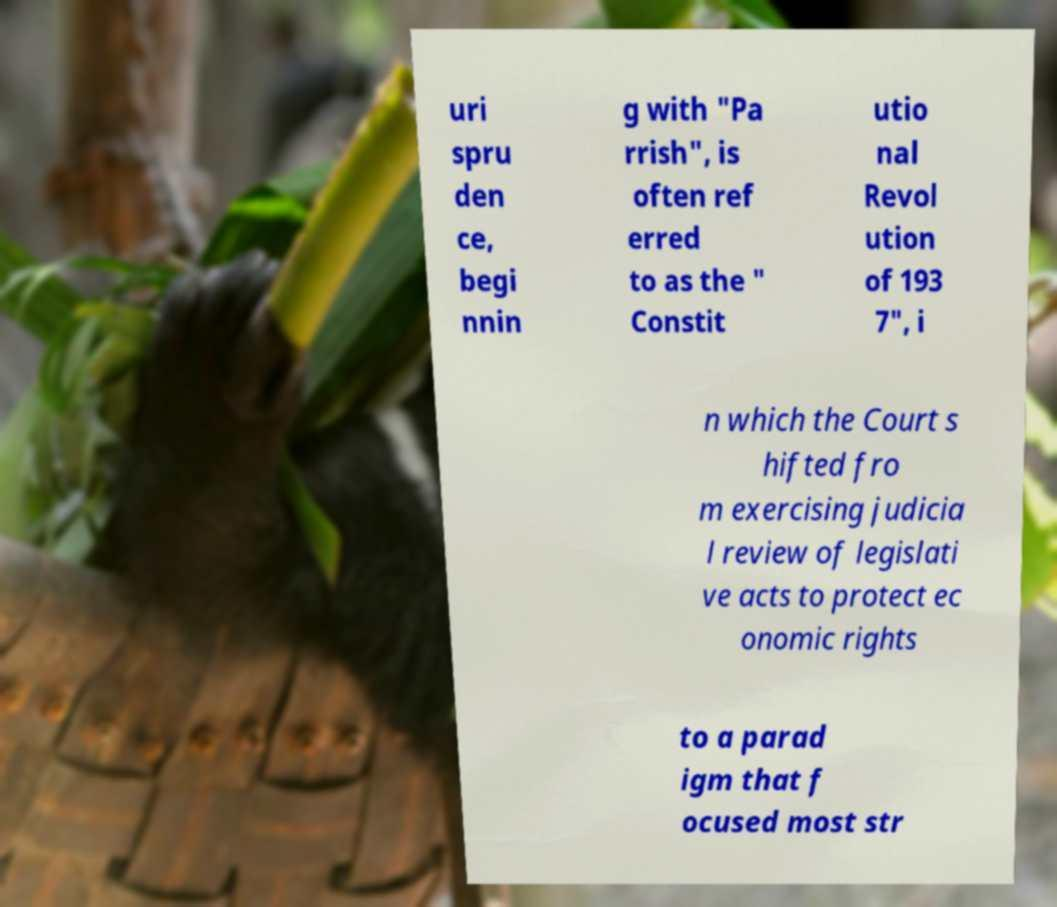There's text embedded in this image that I need extracted. Can you transcribe it verbatim? uri spru den ce, begi nnin g with "Pa rrish", is often ref erred to as the " Constit utio nal Revol ution of 193 7", i n which the Court s hifted fro m exercising judicia l review of legislati ve acts to protect ec onomic rights to a parad igm that f ocused most str 